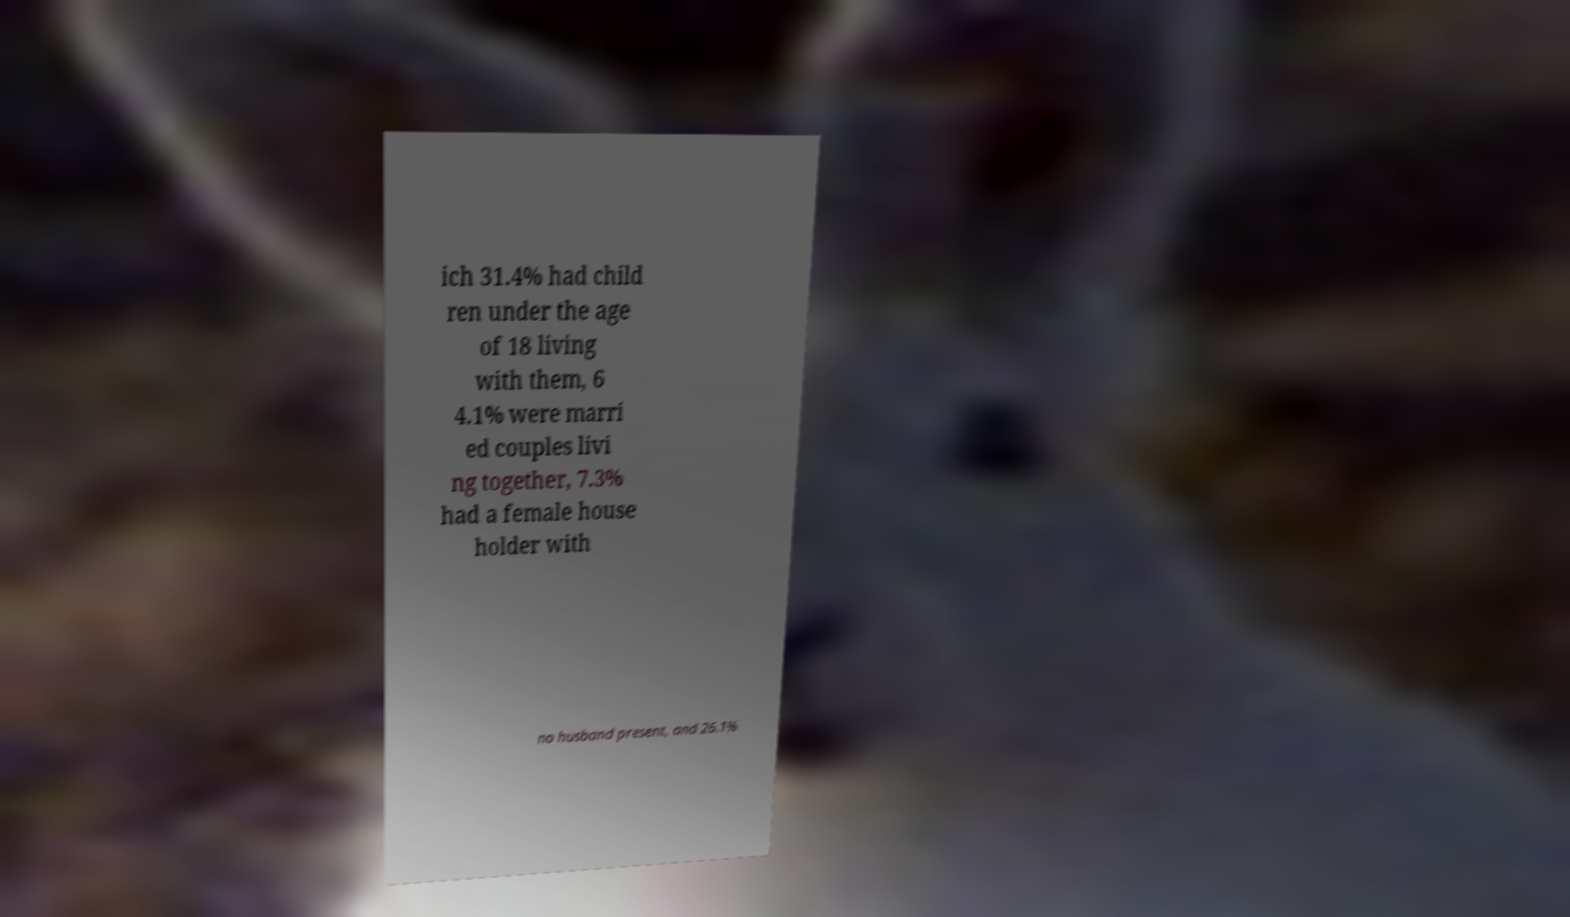Could you assist in decoding the text presented in this image and type it out clearly? ich 31.4% had child ren under the age of 18 living with them, 6 4.1% were marri ed couples livi ng together, 7.3% had a female house holder with no husband present, and 26.1% 